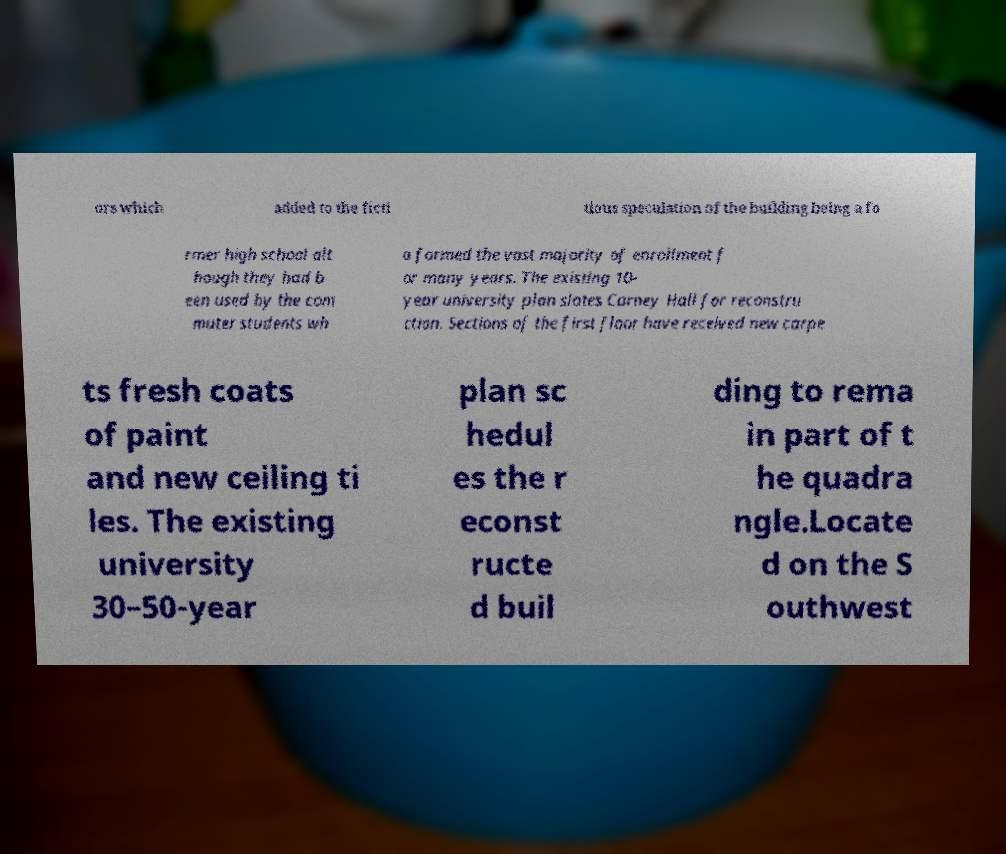Please identify and transcribe the text found in this image. ors which added to the ficti tious speculation of the building being a fo rmer high school alt hough they had b een used by the com muter students wh o formed the vast majority of enrollment f or many years. The existing 10- year university plan slates Carney Hall for reconstru ction. Sections of the first floor have received new carpe ts fresh coats of paint and new ceiling ti les. The existing university 30–50-year plan sc hedul es the r econst ructe d buil ding to rema in part of t he quadra ngle.Locate d on the S outhwest 